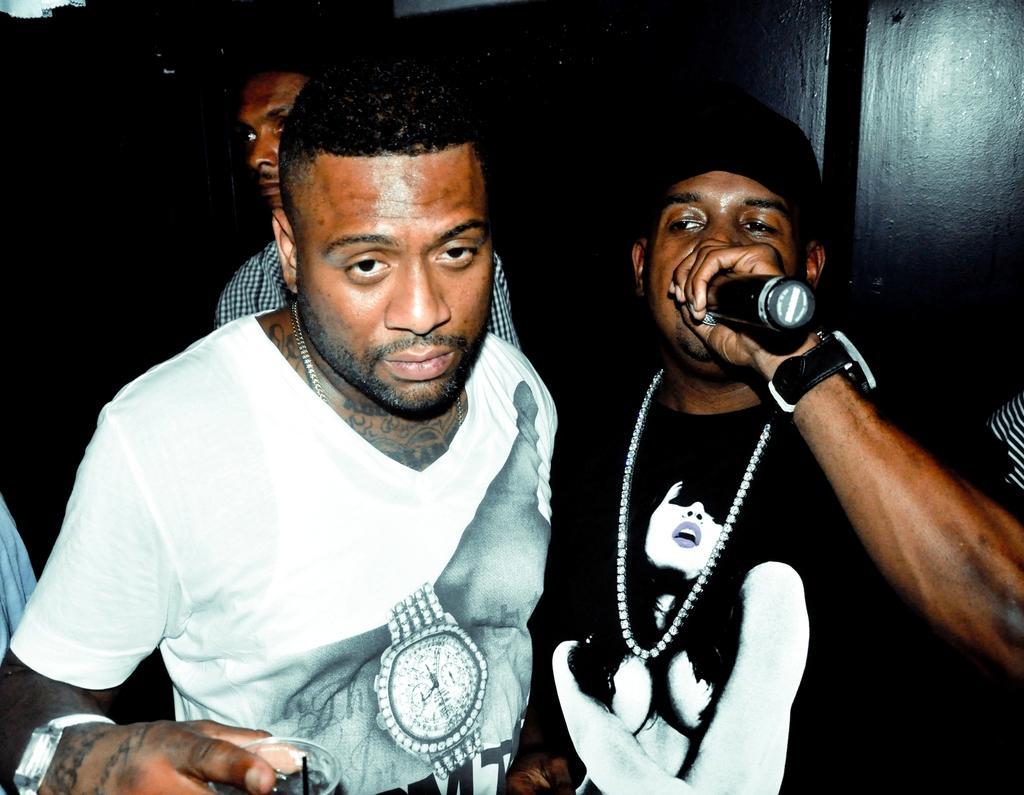Can you describe this image briefly? In this picture we can see three persons here, a man on the left side is holding a glass, a man on the right side is holding a microphone, these two persons wore t-shirts. 